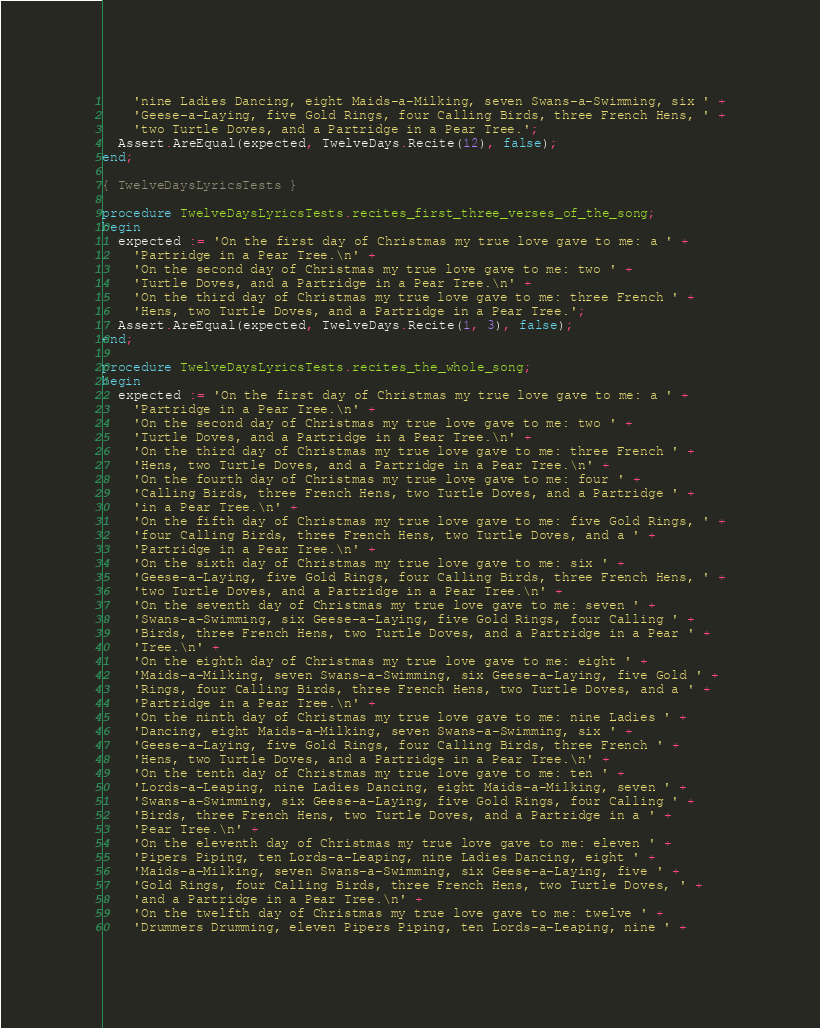Convert code to text. <code><loc_0><loc_0><loc_500><loc_500><_Pascal_>    'nine Ladies Dancing, eight Maids-a-Milking, seven Swans-a-Swimming, six ' +
    'Geese-a-Laying, five Gold Rings, four Calling Birds, three French Hens, ' +
    'two Turtle Doves, and a Partridge in a Pear Tree.';
  Assert.AreEqual(expected, TwelveDays.Recite(12), false);
end;

{ TwelveDaysLyricsTests }

procedure TwelveDaysLyricsTests.recites_first_three_verses_of_the_song;
begin
  expected := 'On the first day of Christmas my true love gave to me: a ' +
    'Partridge in a Pear Tree.\n' +
    'On the second day of Christmas my true love gave to me: two ' +
    'Turtle Doves, and a Partridge in a Pear Tree.\n' +
    'On the third day of Christmas my true love gave to me: three French ' +
    'Hens, two Turtle Doves, and a Partridge in a Pear Tree.';
  Assert.AreEqual(expected, TwelveDays.Recite(1, 3), false);
end;

procedure TwelveDaysLyricsTests.recites_the_whole_song;
begin
  expected := 'On the first day of Christmas my true love gave to me: a ' +
    'Partridge in a Pear Tree.\n' +
    'On the second day of Christmas my true love gave to me: two ' +
    'Turtle Doves, and a Partridge in a Pear Tree.\n' +
    'On the third day of Christmas my true love gave to me: three French ' +
    'Hens, two Turtle Doves, and a Partridge in a Pear Tree.\n' +
    'On the fourth day of Christmas my true love gave to me: four ' +
    'Calling Birds, three French Hens, two Turtle Doves, and a Partridge ' +
    'in a Pear Tree.\n' +
    'On the fifth day of Christmas my true love gave to me: five Gold Rings, ' +
    'four Calling Birds, three French Hens, two Turtle Doves, and a ' +
    'Partridge in a Pear Tree.\n' +
    'On the sixth day of Christmas my true love gave to me: six ' +
    'Geese-a-Laying, five Gold Rings, four Calling Birds, three French Hens, ' +
    'two Turtle Doves, and a Partridge in a Pear Tree.\n' +
    'On the seventh day of Christmas my true love gave to me: seven ' +
    'Swans-a-Swimming, six Geese-a-Laying, five Gold Rings, four Calling ' +
    'Birds, three French Hens, two Turtle Doves, and a Partridge in a Pear ' +
    'Tree.\n' +
    'On the eighth day of Christmas my true love gave to me: eight ' +
    'Maids-a-Milking, seven Swans-a-Swimming, six Geese-a-Laying, five Gold ' +
    'Rings, four Calling Birds, three French Hens, two Turtle Doves, and a ' +
    'Partridge in a Pear Tree.\n' +
    'On the ninth day of Christmas my true love gave to me: nine Ladies ' +
    'Dancing, eight Maids-a-Milking, seven Swans-a-Swimming, six ' +
    'Geese-a-Laying, five Gold Rings, four Calling Birds, three French ' +
    'Hens, two Turtle Doves, and a Partridge in a Pear Tree.\n' +
    'On the tenth day of Christmas my true love gave to me: ten ' +
    'Lords-a-Leaping, nine Ladies Dancing, eight Maids-a-Milking, seven ' +
    'Swans-a-Swimming, six Geese-a-Laying, five Gold Rings, four Calling ' +
    'Birds, three French Hens, two Turtle Doves, and a Partridge in a ' +
    'Pear Tree.\n' +
    'On the eleventh day of Christmas my true love gave to me: eleven ' +
    'Pipers Piping, ten Lords-a-Leaping, nine Ladies Dancing, eight ' +
    'Maids-a-Milking, seven Swans-a-Swimming, six Geese-a-Laying, five ' +
    'Gold Rings, four Calling Birds, three French Hens, two Turtle Doves, ' +
    'and a Partridge in a Pear Tree.\n' +
    'On the twelfth day of Christmas my true love gave to me: twelve ' +
    'Drummers Drumming, eleven Pipers Piping, ten Lords-a-Leaping, nine ' +</code> 